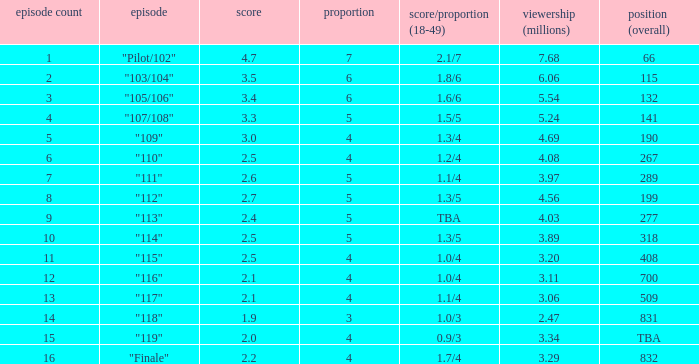WHAT IS THE HIGHEST VIEWERS WITH AN EPISODE LESS THAN 15 AND SHARE LAGER THAN 7? None. 